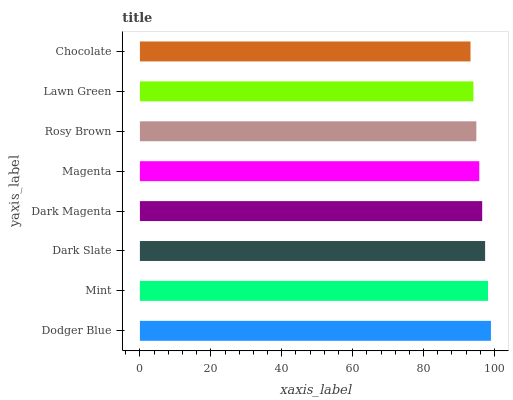Is Chocolate the minimum?
Answer yes or no. Yes. Is Dodger Blue the maximum?
Answer yes or no. Yes. Is Mint the minimum?
Answer yes or no. No. Is Mint the maximum?
Answer yes or no. No. Is Dodger Blue greater than Mint?
Answer yes or no. Yes. Is Mint less than Dodger Blue?
Answer yes or no. Yes. Is Mint greater than Dodger Blue?
Answer yes or no. No. Is Dodger Blue less than Mint?
Answer yes or no. No. Is Dark Magenta the high median?
Answer yes or no. Yes. Is Magenta the low median?
Answer yes or no. Yes. Is Lawn Green the high median?
Answer yes or no. No. Is Dodger Blue the low median?
Answer yes or no. No. 